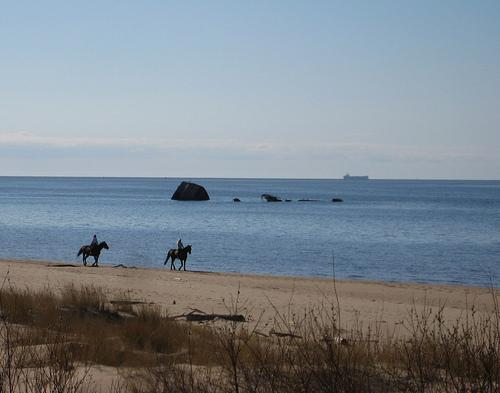Which actor has the training to do what these people are doing? horseback riding 